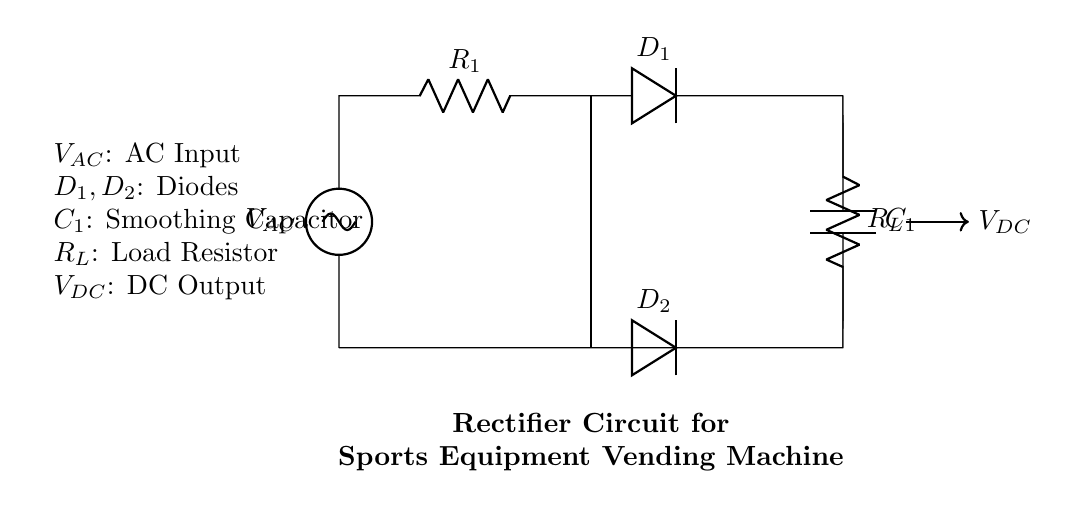What is the input voltage of this circuit? The input voltage is represented by \( V_{AC} \), shown as the AC voltage source on the left side of the circuit diagram.
Answer: \( V_{AC} \) What are the names of the diodes in the circuit? The circuit contains two diodes named \( D_1 \) and \( D_2 \), which are positioned in the path of current after the resistor and capacitor.
Answer: \( D_1, D_2 \) What does the smoothing capacitor do in this circuit? The smoothing capacitor \( C_1 \) is used to reduce voltage fluctuations by storing charge and providing a more stable DC output.
Answer: Stabilizes voltage What type of rectifier is represented in this circuit? The circuit type is a full-wave rectifier, as it uses two diodes to rectify both halves of the AC signal into DC.
Answer: Full-wave How does the load resistor affect the circuit performance? The load resistor \( R_L \) consumes power and dictates how much current can flow through the circuit, influencing the overall output voltage and current.
Answer: Dictates current What is the output voltage of the rectifier circuit? The output voltage \( V_{DC} \) is the smoothed direct current voltage that appears across the load resistor \( R_L \), after rectification and smoothing.
Answer: \( V_{DC} \) Which component is primarily responsible for converting AC to DC? The primary component responsible for converting AC to DC is the pair of diodes \( D_1 \) and \( D_2 \), which allow current to pass in only one direction.
Answer: Diodes \( D_1, D_2 \) 